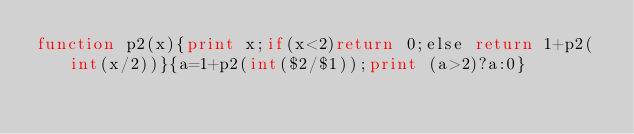Convert code to text. <code><loc_0><loc_0><loc_500><loc_500><_Awk_>function p2(x){print x;if(x<2)return 0;else return 1+p2(int(x/2))}{a=1+p2(int($2/$1));print (a>2)?a:0}</code> 